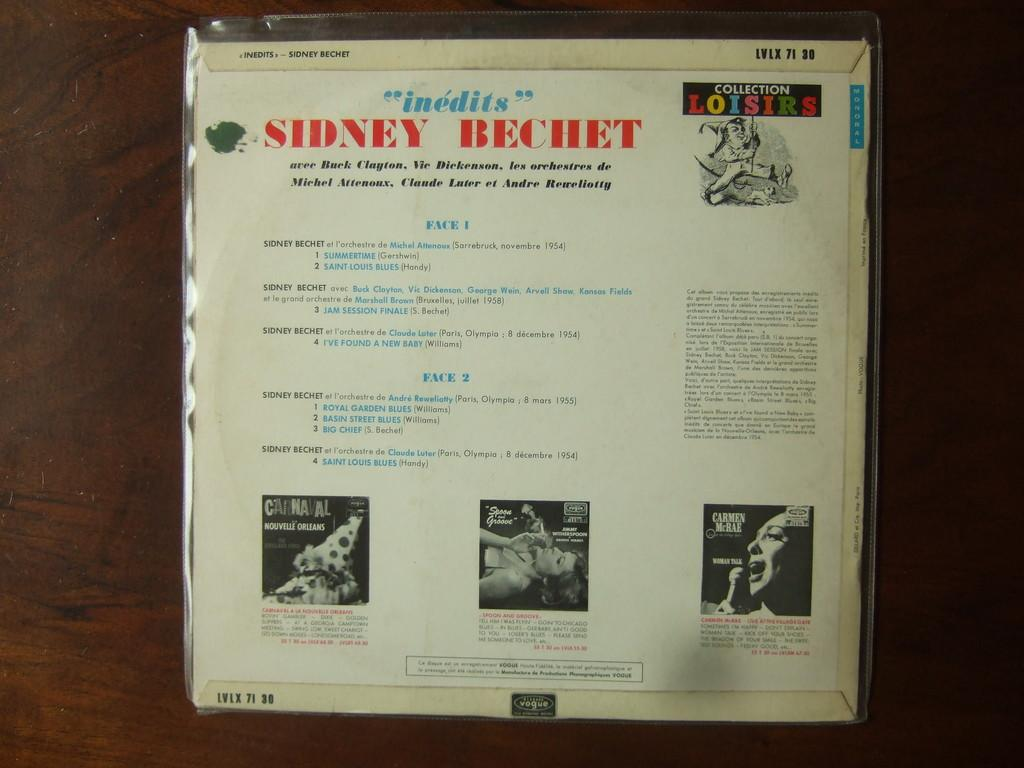<image>
Render a clear and concise summary of the photo. an info page by Sidney becket with three different illustrations on the bottom. 